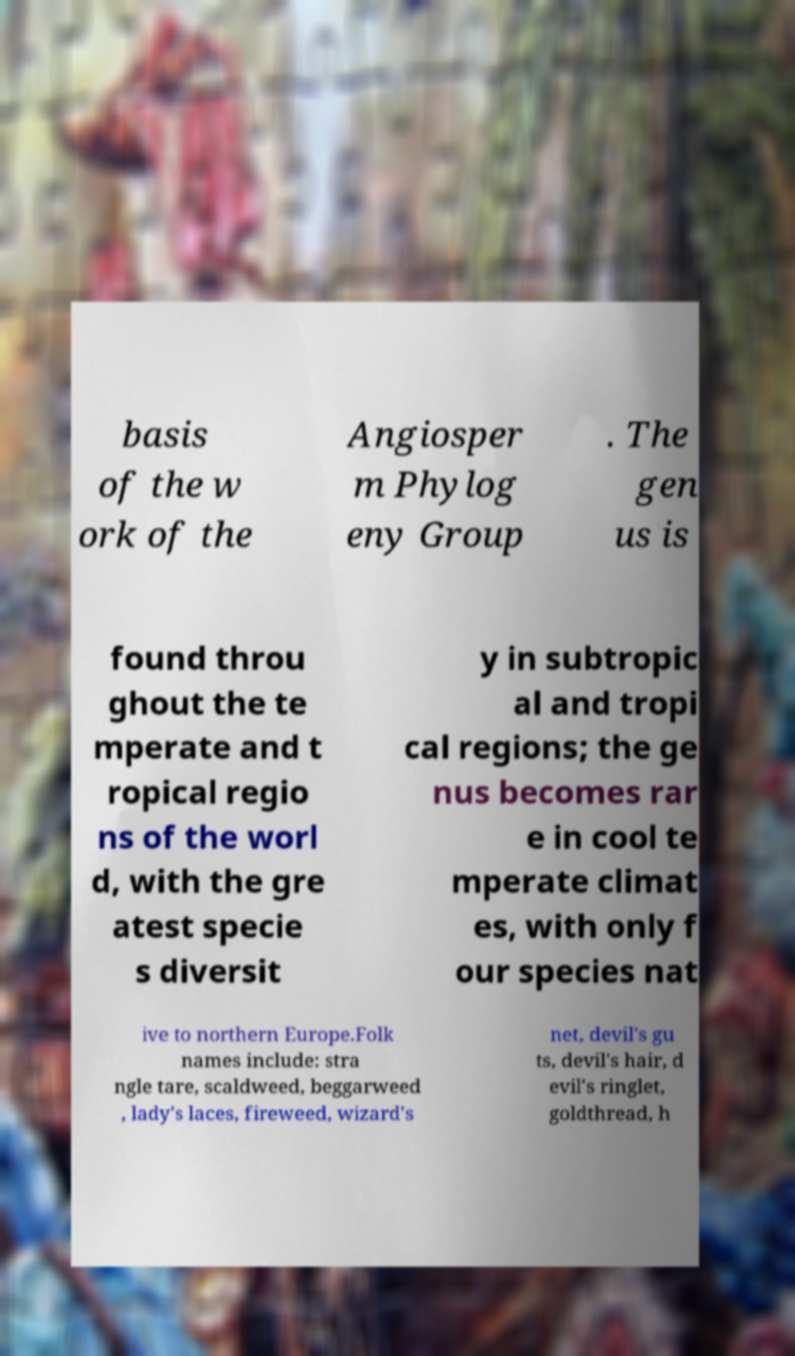Could you assist in decoding the text presented in this image and type it out clearly? basis of the w ork of the Angiosper m Phylog eny Group . The gen us is found throu ghout the te mperate and t ropical regio ns of the worl d, with the gre atest specie s diversit y in subtropic al and tropi cal regions; the ge nus becomes rar e in cool te mperate climat es, with only f our species nat ive to northern Europe.Folk names include: stra ngle tare, scaldweed, beggarweed , lady's laces, fireweed, wizard's net, devil's gu ts, devil's hair, d evil's ringlet, goldthread, h 